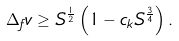<formula> <loc_0><loc_0><loc_500><loc_500>\Delta _ { f } v \geq S ^ { \frac { 1 } { 2 } } \left ( 1 - c _ { k } S ^ { \frac { 3 } { 4 } } \right ) .</formula> 